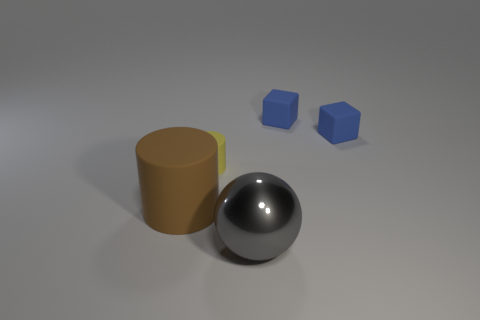Are there any other things that have the same material as the large gray sphere?
Provide a short and direct response. No. What is the material of the thing that is both to the left of the gray object and to the right of the large brown matte cylinder?
Offer a very short reply. Rubber. Is the number of cylinders less than the number of big brown things?
Your response must be concise. No. Do the big matte object and the small rubber thing on the left side of the large shiny thing have the same shape?
Your answer should be very brief. Yes. There is a cylinder that is to the right of the brown object; is it the same size as the big gray object?
Ensure brevity in your answer.  No. There is a brown matte object that is the same size as the gray object; what shape is it?
Make the answer very short. Cylinder. Is the large brown object the same shape as the small yellow rubber thing?
Ensure brevity in your answer.  Yes. What number of other big gray objects are the same shape as the shiny thing?
Make the answer very short. 0. How many big objects are behind the gray metallic object?
Your answer should be compact. 1. What number of matte blocks have the same size as the brown object?
Provide a succinct answer. 0. 